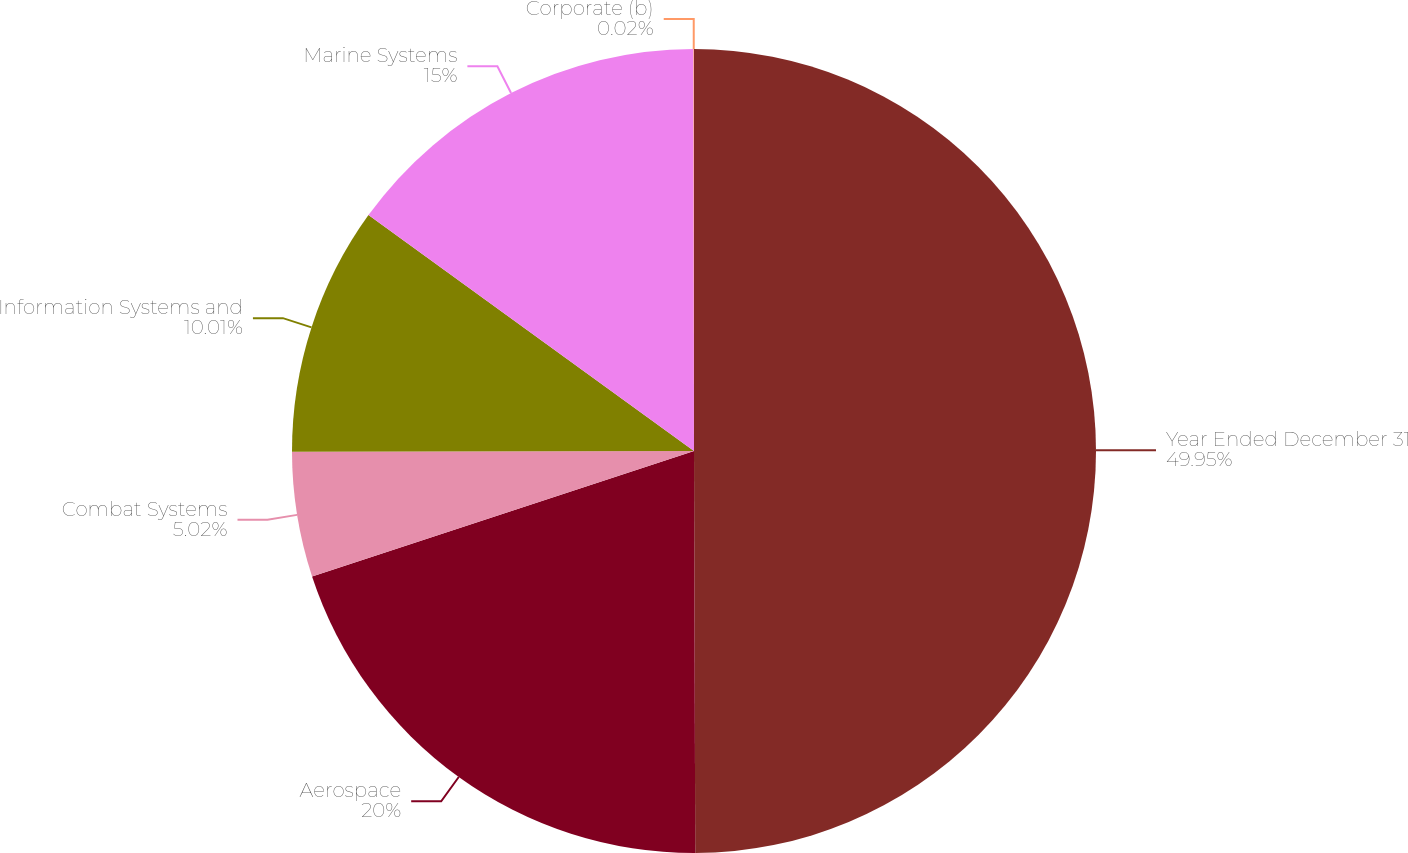<chart> <loc_0><loc_0><loc_500><loc_500><pie_chart><fcel>Year Ended December 31<fcel>Aerospace<fcel>Combat Systems<fcel>Information Systems and<fcel>Marine Systems<fcel>Corporate (b)<nl><fcel>49.95%<fcel>20.0%<fcel>5.02%<fcel>10.01%<fcel>15.0%<fcel>0.02%<nl></chart> 